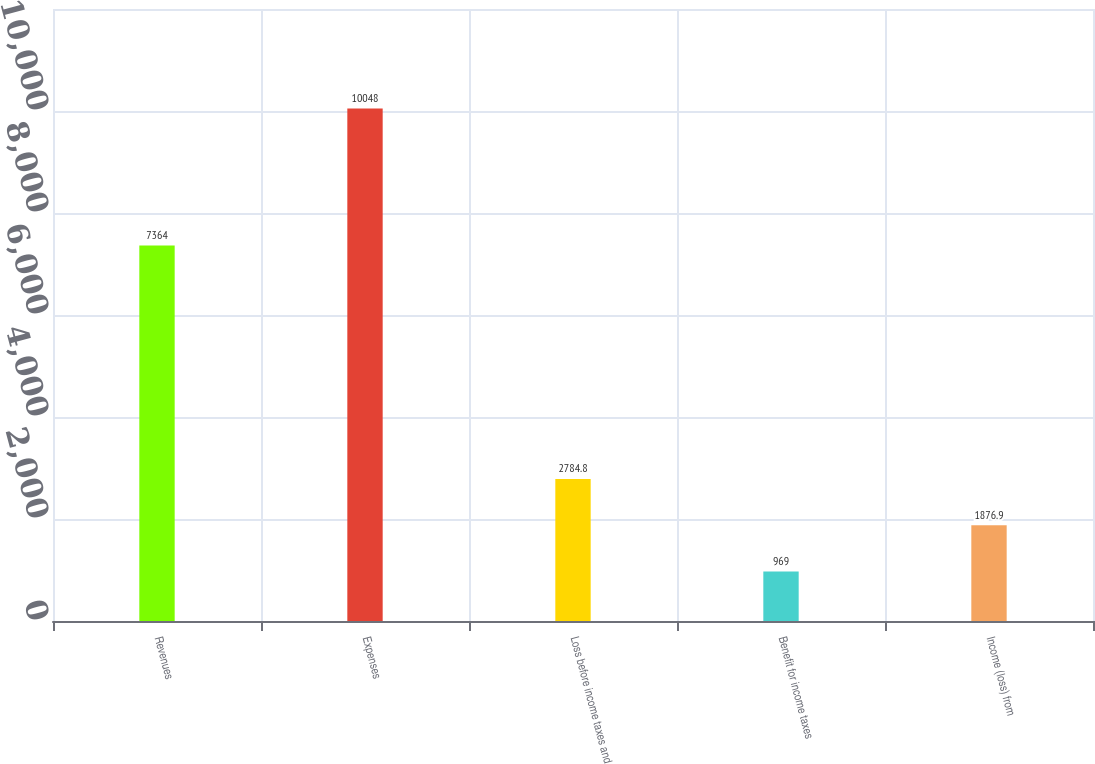<chart> <loc_0><loc_0><loc_500><loc_500><bar_chart><fcel>Revenues<fcel>Expenses<fcel>Loss before income taxes and<fcel>Benefit for income taxes<fcel>Income (loss) from<nl><fcel>7364<fcel>10048<fcel>2784.8<fcel>969<fcel>1876.9<nl></chart> 